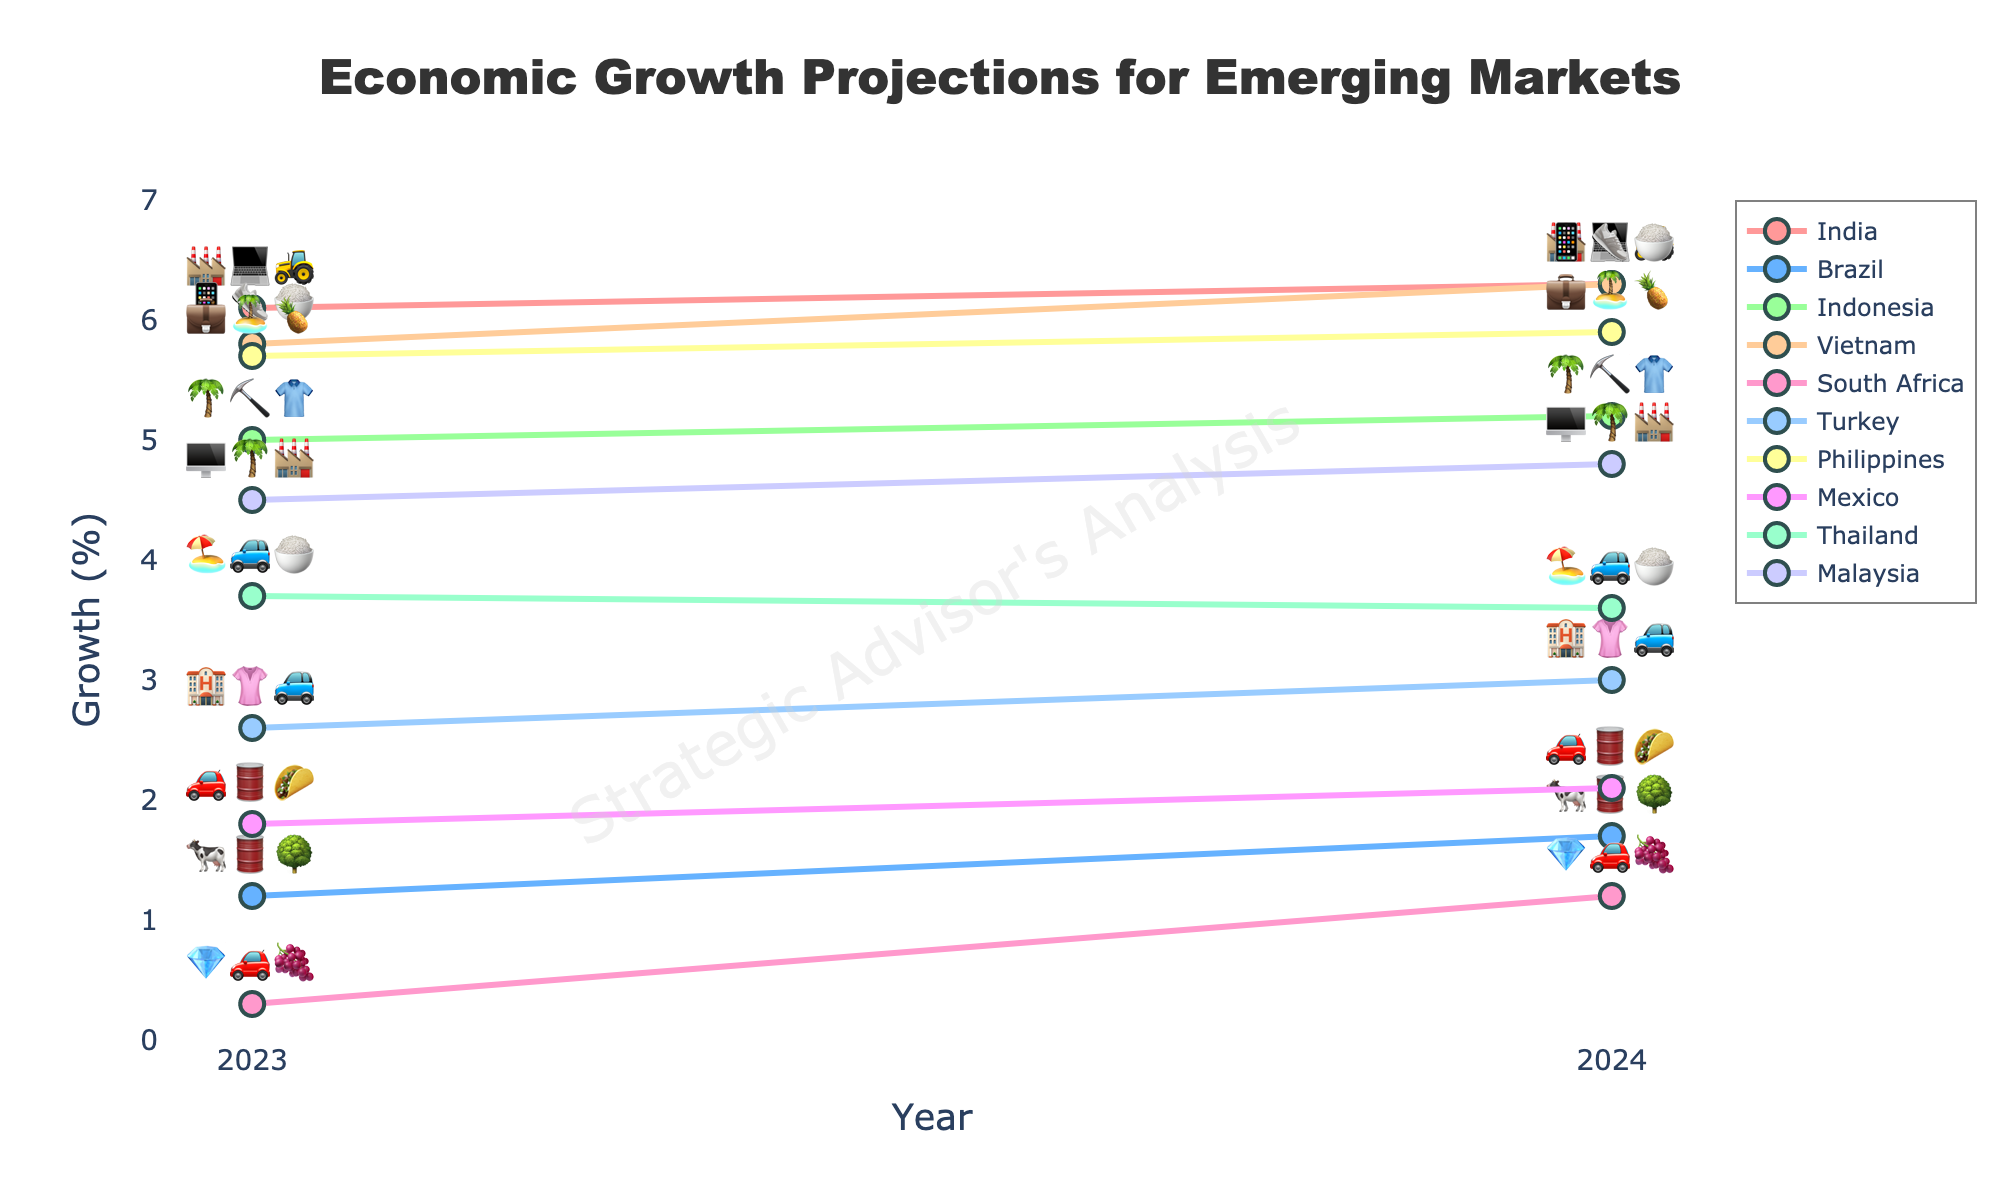What is the projected economic growth rate for India in 2024? The figure shows the economic growth projections for each emerging market country for the years 2023 and 2024. Look at the projected growth rate for India in 2024.
Answer: 6.3% Which country has the lowest growth rate in 2023? The figure shows growth projections for all countries in 2023. Look for the country with the smallest growth percentage.
Answer: South Africa What are the key industries for Brazil in the plot? Each country has emojis representing their key industries above their growth lines. Look for those associated with Brazil.
Answer: 🐄🛢️🌳 Compare the growth rate of Indonesia and Thailand in 2023. Which country has a higher growth rate? Find the 2023 growth rates for Indonesia and Thailand. Compare the two values to determine the higher one.
Answer: Indonesia What is the difference in growth rates between Turkey in 2023 and 2024? Note Turkey's growth rates for both years and subtract the 2023 rate from the 2024 rate to find the difference.
Answer: 0.4% Which countries have a projected growth rate of 6.3% in 2024? Look for the countries with lines ending at 6.3% on the 2024 vertical axis. Note their names.
Answer: India and Vietnam What is the average projected growth rate for the Philippines across 2023 and 2024? Take the Philippines' projected growth rates for both years, sum them, and divide by 2 to get the average.
Answer: 5.8% How do the growth rates for Mexico and South Africa compare in 2024? Note the growth rates for both countries in 2024 and compare them.
Answer: Mexico has a higher growth rate What key industries are represented by the emojis 💎🚗🍇? Identify the country associated with the key industries represented by these emojis.
Answer: South Africa What is the growth trend for Malaysia from 2023 to 2024? Look at Malaysia's growth percentages for both years and determine if it is increasing, decreasing, or staying the same.
Answer: Increasing 